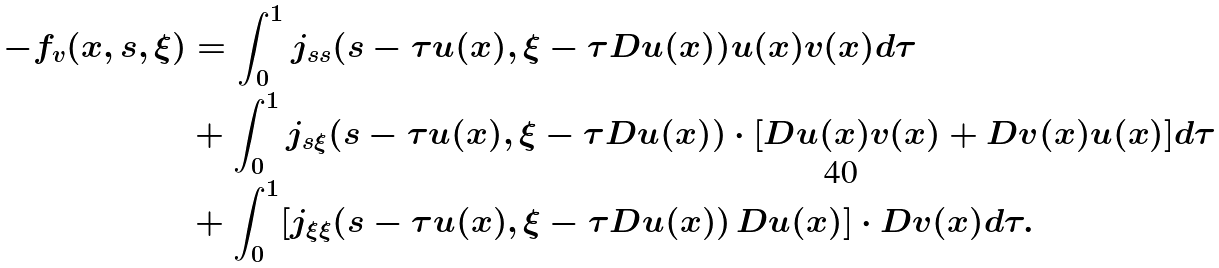<formula> <loc_0><loc_0><loc_500><loc_500>- f _ { v } ( x , s , \xi ) & = \int ^ { 1 } _ { 0 } j _ { s s } ( s - \tau u ( x ) , \xi - \tau D u ( x ) ) u ( x ) v ( x ) d \tau \\ & + \int ^ { 1 } _ { 0 } j _ { s \xi } ( s - \tau u ( x ) , \xi - \tau D u ( x ) ) \cdot [ D u ( x ) v ( x ) + D v ( x ) u ( x ) ] d \tau \\ & + \int ^ { 1 } _ { 0 } [ j _ { \xi \xi } ( s - \tau u ( x ) , \xi - \tau D u ( x ) ) \, D u ( x ) ] \cdot D v ( x ) d \tau .</formula> 